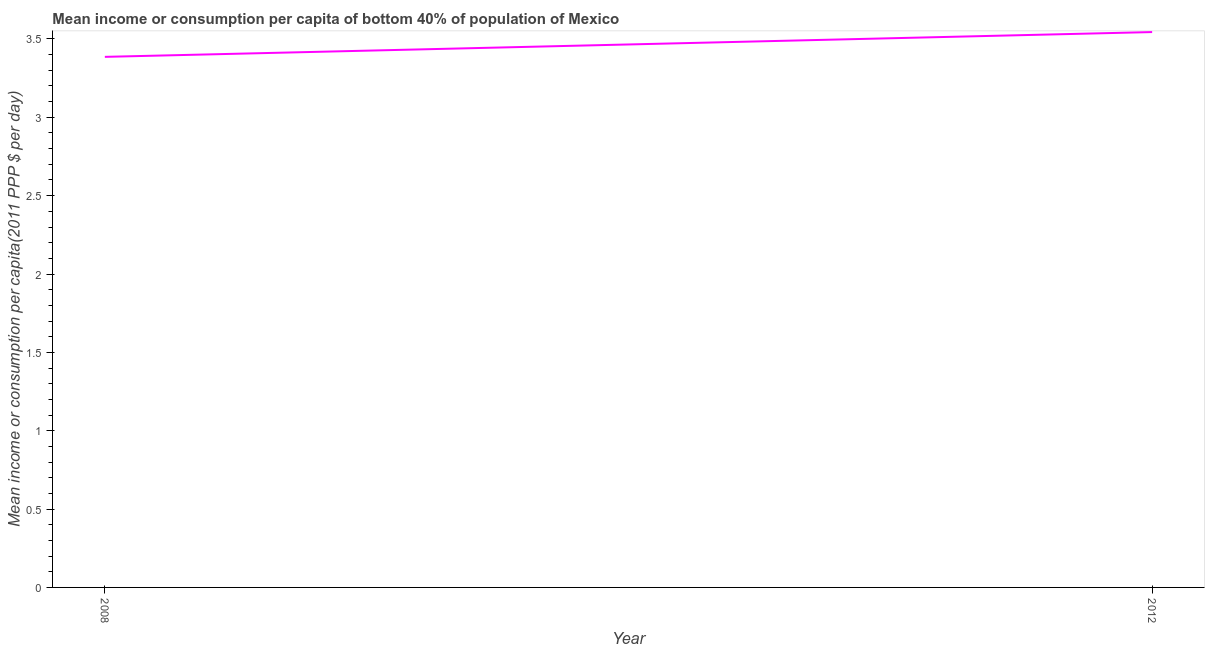What is the mean income or consumption in 2012?
Your response must be concise. 3.54. Across all years, what is the maximum mean income or consumption?
Make the answer very short. 3.54. Across all years, what is the minimum mean income or consumption?
Provide a short and direct response. 3.39. What is the sum of the mean income or consumption?
Provide a short and direct response. 6.93. What is the difference between the mean income or consumption in 2008 and 2012?
Your answer should be very brief. -0.16. What is the average mean income or consumption per year?
Your answer should be very brief. 3.46. What is the median mean income or consumption?
Give a very brief answer. 3.46. In how many years, is the mean income or consumption greater than 0.6 $?
Offer a very short reply. 2. What is the ratio of the mean income or consumption in 2008 to that in 2012?
Keep it short and to the point. 0.96. Is the mean income or consumption in 2008 less than that in 2012?
Provide a short and direct response. Yes. How many lines are there?
Make the answer very short. 1. What is the difference between two consecutive major ticks on the Y-axis?
Your answer should be very brief. 0.5. Does the graph contain any zero values?
Offer a very short reply. No. What is the title of the graph?
Your answer should be very brief. Mean income or consumption per capita of bottom 40% of population of Mexico. What is the label or title of the Y-axis?
Offer a very short reply. Mean income or consumption per capita(2011 PPP $ per day). What is the Mean income or consumption per capita(2011 PPP $ per day) of 2008?
Offer a terse response. 3.39. What is the Mean income or consumption per capita(2011 PPP $ per day) of 2012?
Offer a terse response. 3.54. What is the difference between the Mean income or consumption per capita(2011 PPP $ per day) in 2008 and 2012?
Your answer should be very brief. -0.16. What is the ratio of the Mean income or consumption per capita(2011 PPP $ per day) in 2008 to that in 2012?
Give a very brief answer. 0.95. 